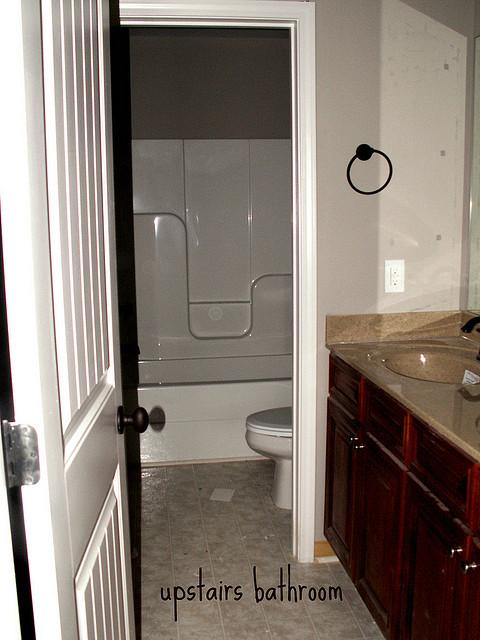Is there a plant upstairs?
Answer briefly. No. What color is the towel hanger?
Concise answer only. Black. Is the door closed?
Write a very short answer. No. What color are the counters in the bathroom?
Answer briefly. Tan. Is this a men's room or women's room?
Write a very short answer. Both. 